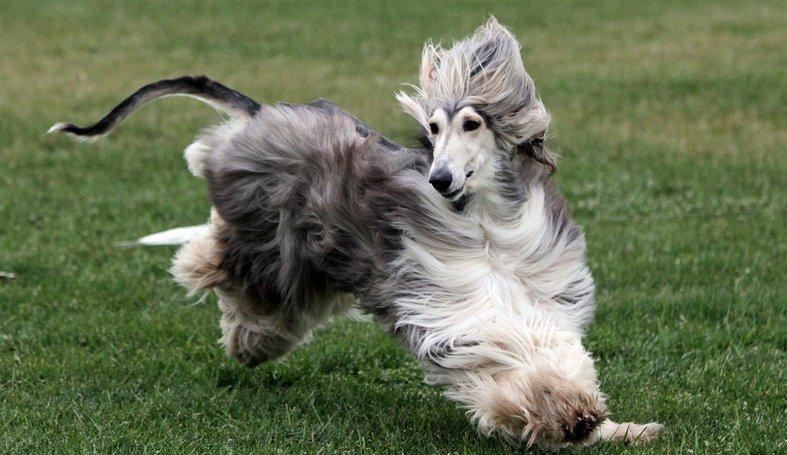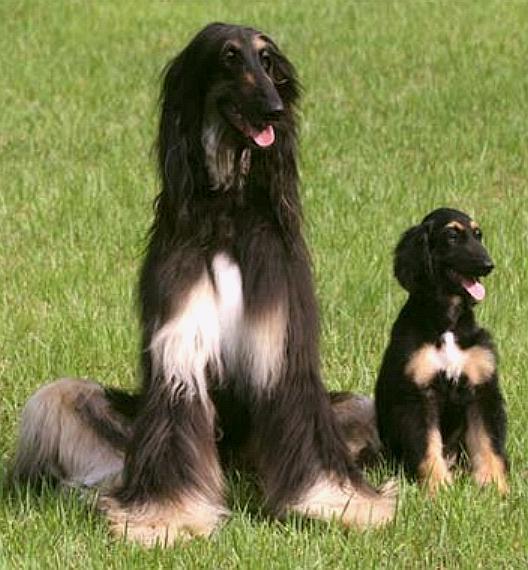The first image is the image on the left, the second image is the image on the right. Given the left and right images, does the statement "At least one image shows a dog bounding across the grass." hold true? Answer yes or no. Yes. 